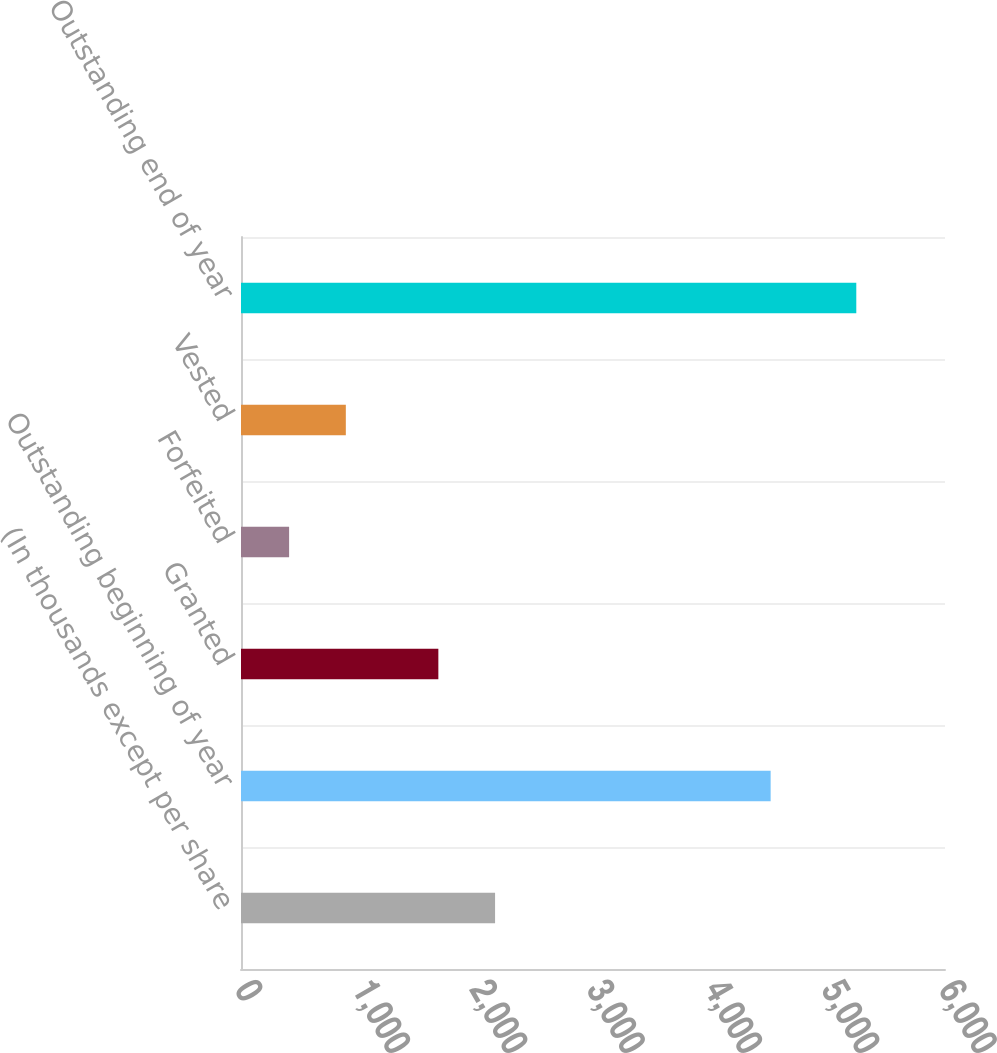Convert chart to OTSL. <chart><loc_0><loc_0><loc_500><loc_500><bar_chart><fcel>(In thousands except per share<fcel>Outstanding beginning of year<fcel>Granted<fcel>Forfeited<fcel>Vested<fcel>Outstanding end of year<nl><fcel>2165.4<fcel>4514<fcel>1682<fcel>410<fcel>893.4<fcel>5244<nl></chart> 